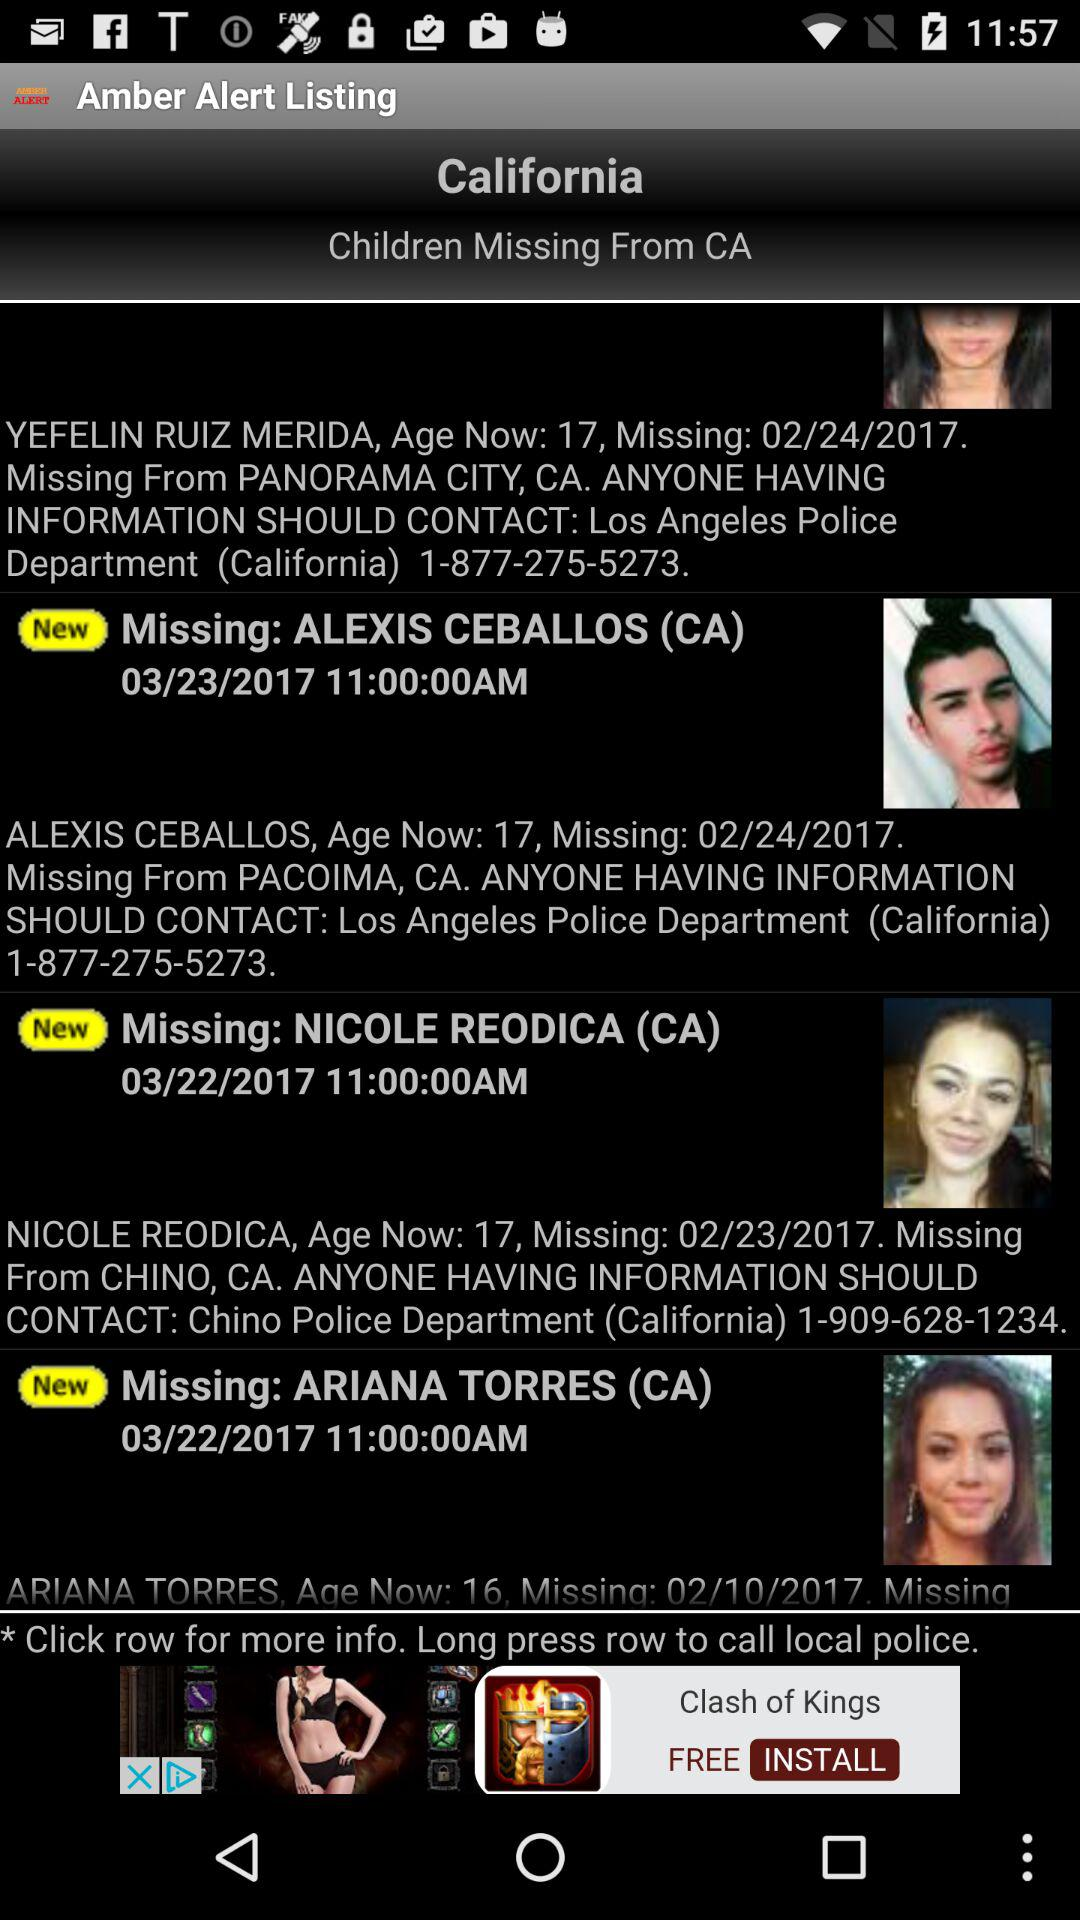What is the given location? The given locations are Panorama City, CA; Pacoima, CA and Chino, CA. 